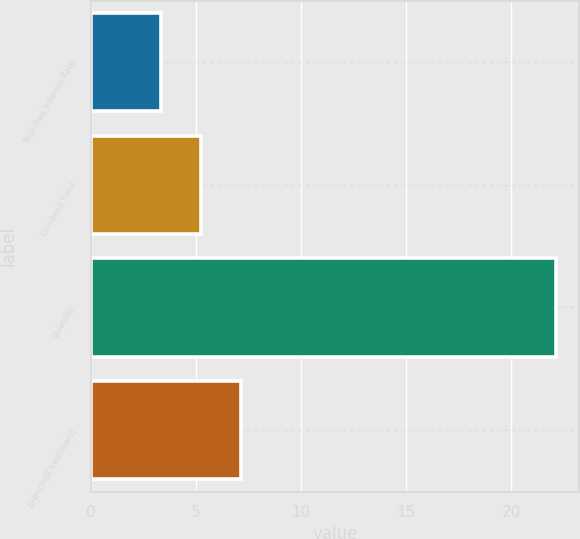Convert chart to OTSL. <chart><loc_0><loc_0><loc_500><loc_500><bar_chart><fcel>Risk-free Interest Rate<fcel>Dividend Yield<fcel>Volatility<fcel>ExpectedLives(Years)<nl><fcel>3.36<fcel>5.24<fcel>22.12<fcel>7.12<nl></chart> 